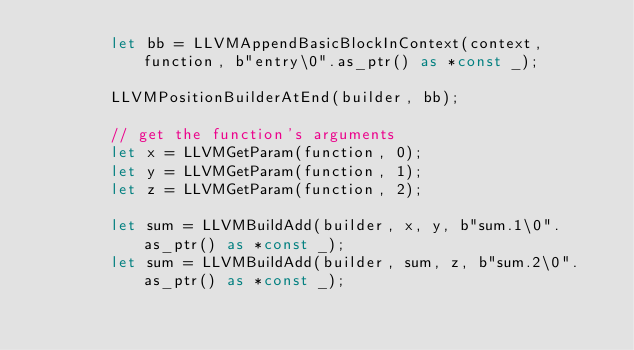<code> <loc_0><loc_0><loc_500><loc_500><_Rust_>        let bb = LLVMAppendBasicBlockInContext(context, function, b"entry\0".as_ptr() as *const _);

        LLVMPositionBuilderAtEnd(builder, bb);

        // get the function's arguments
        let x = LLVMGetParam(function, 0);
        let y = LLVMGetParam(function, 1);
        let z = LLVMGetParam(function, 2);

        let sum = LLVMBuildAdd(builder, x, y, b"sum.1\0".as_ptr() as *const _);
        let sum = LLVMBuildAdd(builder, sum, z, b"sum.2\0".as_ptr() as *const _);
</code> 